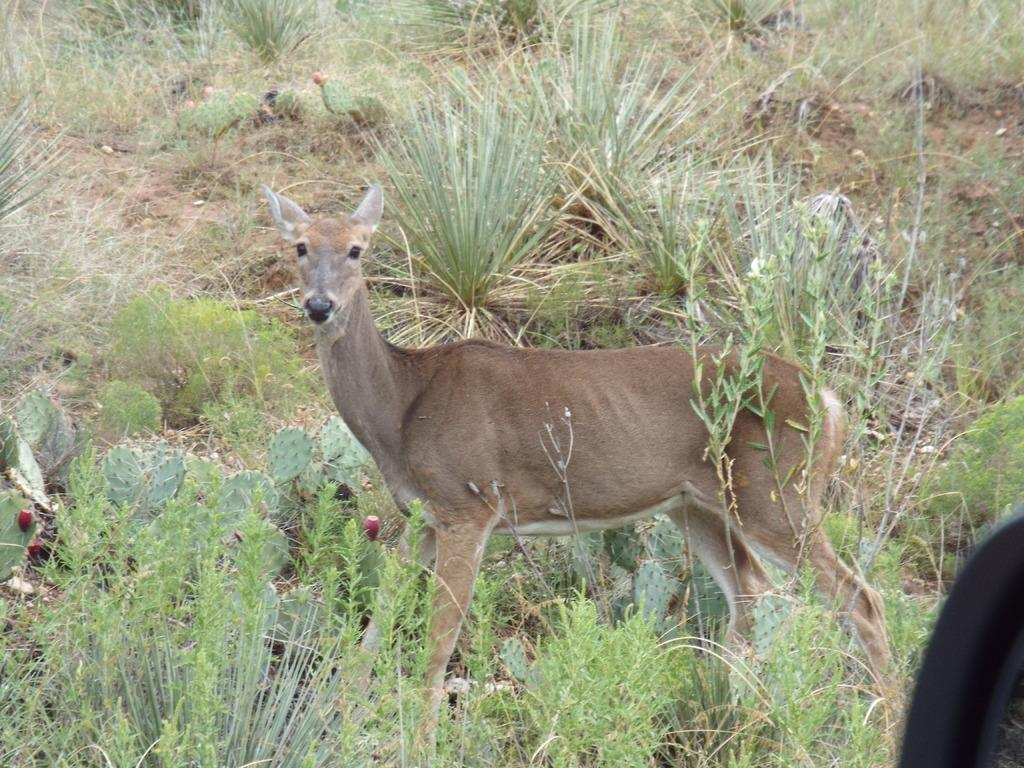What animal is present in the image? There is a deer in the image. What type of vegetation is visible behind the deer? There is grass behind the deer. Can you describe the object located on the bottom left of the image? Unfortunately, the provided facts do not give any information about the object on the bottom left of the image. How old is the girl playing the instrument in the image? There is no girl or instrument present in the image; it features a deer and grass. 